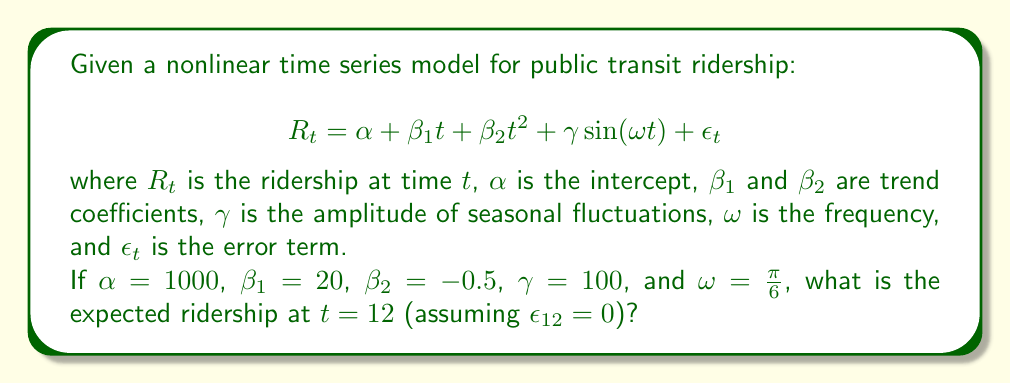Can you solve this math problem? To solve this problem, we'll follow these steps:

1) We're given the nonlinear time series model:

   $$R_t = \alpha + \beta_1 t + \beta_2 t^2 + \gamma \sin(\omega t) + \epsilon_t$$

2) We're also given the following parameter values:
   $\alpha = 1000$, $\beta_1 = 20$, $\beta_2 = -0.5$, $\gamma = 100$, $\omega = \frac{\pi}{6}$, and $t = 12$

3) We assume $\epsilon_{12} = 0$ (no error term at $t = 12$)

4) Let's substitute these values into the equation:

   $$R_{12} = 1000 + 20(12) + (-0.5)(12)^2 + 100 \sin(\frac{\pi}{6} \cdot 12)$$

5) Let's calculate each term:
   - $1000$ (constant term)
   - $20(12) = 240$
   - $(-0.5)(12)^2 = (-0.5)(144) = -72$
   - $100 \sin(\frac{\pi}{6} \cdot 12) = 100 \sin(2\pi) = 0$ (since $\sin(2\pi) = 0$)

6) Now, let's sum up all the terms:

   $$R_{12} = 1000 + 240 - 72 + 0 = 1168$$

Therefore, the expected ridership at $t = 12$ is 1168.
Answer: 1168 